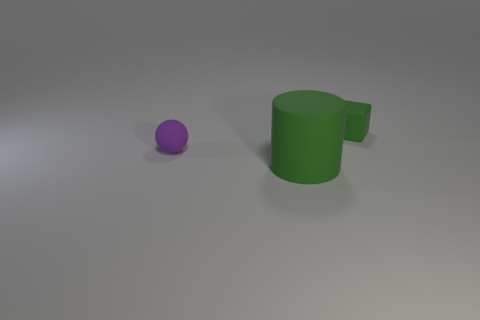Add 3 big red cubes. How many objects exist? 6 Subtract all cylinders. How many objects are left? 2 Add 3 large rubber cylinders. How many large rubber cylinders are left? 4 Add 1 large green matte objects. How many large green matte objects exist? 2 Subtract 0 purple cylinders. How many objects are left? 3 Subtract all small matte blocks. Subtract all large green objects. How many objects are left? 1 